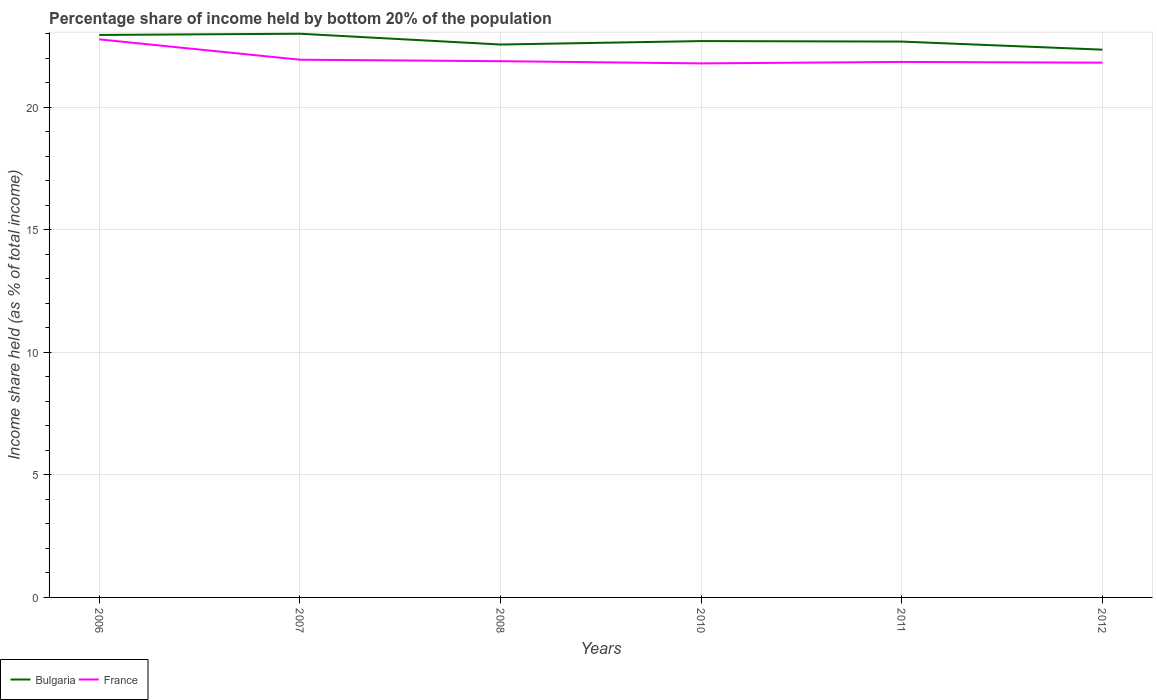Does the line corresponding to Bulgaria intersect with the line corresponding to France?
Your answer should be compact. No. Is the number of lines equal to the number of legend labels?
Make the answer very short. Yes. Across all years, what is the maximum share of income held by bottom 20% of the population in France?
Give a very brief answer. 21.79. In which year was the share of income held by bottom 20% of the population in France maximum?
Give a very brief answer. 2010. What is the total share of income held by bottom 20% of the population in Bulgaria in the graph?
Ensure brevity in your answer.  0.39. What is the difference between the highest and the second highest share of income held by bottom 20% of the population in France?
Make the answer very short. 0.98. What is the difference between the highest and the lowest share of income held by bottom 20% of the population in Bulgaria?
Your answer should be very brief. 2. Is the share of income held by bottom 20% of the population in France strictly greater than the share of income held by bottom 20% of the population in Bulgaria over the years?
Make the answer very short. Yes. How many lines are there?
Keep it short and to the point. 2. What is the difference between two consecutive major ticks on the Y-axis?
Provide a short and direct response. 5. Are the values on the major ticks of Y-axis written in scientific E-notation?
Provide a succinct answer. No. What is the title of the graph?
Keep it short and to the point. Percentage share of income held by bottom 20% of the population. Does "Palau" appear as one of the legend labels in the graph?
Provide a short and direct response. No. What is the label or title of the Y-axis?
Your answer should be very brief. Income share held (as % of total income). What is the Income share held (as % of total income) of Bulgaria in 2006?
Offer a terse response. 22.95. What is the Income share held (as % of total income) in France in 2006?
Ensure brevity in your answer.  22.77. What is the Income share held (as % of total income) of France in 2007?
Make the answer very short. 21.94. What is the Income share held (as % of total income) in Bulgaria in 2008?
Make the answer very short. 22.56. What is the Income share held (as % of total income) in France in 2008?
Offer a very short reply. 21.88. What is the Income share held (as % of total income) of Bulgaria in 2010?
Keep it short and to the point. 22.7. What is the Income share held (as % of total income) of France in 2010?
Your response must be concise. 21.79. What is the Income share held (as % of total income) in Bulgaria in 2011?
Provide a succinct answer. 22.68. What is the Income share held (as % of total income) of France in 2011?
Your answer should be compact. 21.85. What is the Income share held (as % of total income) in Bulgaria in 2012?
Your response must be concise. 22.35. What is the Income share held (as % of total income) in France in 2012?
Ensure brevity in your answer.  21.82. Across all years, what is the maximum Income share held (as % of total income) in France?
Keep it short and to the point. 22.77. Across all years, what is the minimum Income share held (as % of total income) of Bulgaria?
Make the answer very short. 22.35. Across all years, what is the minimum Income share held (as % of total income) in France?
Offer a very short reply. 21.79. What is the total Income share held (as % of total income) in Bulgaria in the graph?
Give a very brief answer. 136.24. What is the total Income share held (as % of total income) of France in the graph?
Give a very brief answer. 132.05. What is the difference between the Income share held (as % of total income) in France in 2006 and that in 2007?
Give a very brief answer. 0.83. What is the difference between the Income share held (as % of total income) of Bulgaria in 2006 and that in 2008?
Offer a terse response. 0.39. What is the difference between the Income share held (as % of total income) in France in 2006 and that in 2008?
Offer a very short reply. 0.89. What is the difference between the Income share held (as % of total income) of Bulgaria in 2006 and that in 2011?
Make the answer very short. 0.27. What is the difference between the Income share held (as % of total income) of Bulgaria in 2007 and that in 2008?
Give a very brief answer. 0.44. What is the difference between the Income share held (as % of total income) of Bulgaria in 2007 and that in 2010?
Provide a succinct answer. 0.3. What is the difference between the Income share held (as % of total income) of France in 2007 and that in 2010?
Provide a short and direct response. 0.15. What is the difference between the Income share held (as % of total income) in Bulgaria in 2007 and that in 2011?
Provide a short and direct response. 0.32. What is the difference between the Income share held (as % of total income) in France in 2007 and that in 2011?
Your response must be concise. 0.09. What is the difference between the Income share held (as % of total income) of Bulgaria in 2007 and that in 2012?
Provide a short and direct response. 0.65. What is the difference between the Income share held (as % of total income) in France in 2007 and that in 2012?
Keep it short and to the point. 0.12. What is the difference between the Income share held (as % of total income) of Bulgaria in 2008 and that in 2010?
Your answer should be very brief. -0.14. What is the difference between the Income share held (as % of total income) in France in 2008 and that in 2010?
Give a very brief answer. 0.09. What is the difference between the Income share held (as % of total income) of Bulgaria in 2008 and that in 2011?
Offer a very short reply. -0.12. What is the difference between the Income share held (as % of total income) in France in 2008 and that in 2011?
Make the answer very short. 0.03. What is the difference between the Income share held (as % of total income) of Bulgaria in 2008 and that in 2012?
Provide a short and direct response. 0.21. What is the difference between the Income share held (as % of total income) in France in 2008 and that in 2012?
Make the answer very short. 0.06. What is the difference between the Income share held (as % of total income) in Bulgaria in 2010 and that in 2011?
Make the answer very short. 0.02. What is the difference between the Income share held (as % of total income) in France in 2010 and that in 2011?
Offer a terse response. -0.06. What is the difference between the Income share held (as % of total income) of France in 2010 and that in 2012?
Offer a very short reply. -0.03. What is the difference between the Income share held (as % of total income) of Bulgaria in 2011 and that in 2012?
Your answer should be compact. 0.33. What is the difference between the Income share held (as % of total income) in France in 2011 and that in 2012?
Provide a short and direct response. 0.03. What is the difference between the Income share held (as % of total income) in Bulgaria in 2006 and the Income share held (as % of total income) in France in 2007?
Give a very brief answer. 1.01. What is the difference between the Income share held (as % of total income) in Bulgaria in 2006 and the Income share held (as % of total income) in France in 2008?
Your response must be concise. 1.07. What is the difference between the Income share held (as % of total income) of Bulgaria in 2006 and the Income share held (as % of total income) of France in 2010?
Make the answer very short. 1.16. What is the difference between the Income share held (as % of total income) in Bulgaria in 2006 and the Income share held (as % of total income) in France in 2011?
Keep it short and to the point. 1.1. What is the difference between the Income share held (as % of total income) in Bulgaria in 2006 and the Income share held (as % of total income) in France in 2012?
Your answer should be compact. 1.13. What is the difference between the Income share held (as % of total income) in Bulgaria in 2007 and the Income share held (as % of total income) in France in 2008?
Keep it short and to the point. 1.12. What is the difference between the Income share held (as % of total income) in Bulgaria in 2007 and the Income share held (as % of total income) in France in 2010?
Ensure brevity in your answer.  1.21. What is the difference between the Income share held (as % of total income) of Bulgaria in 2007 and the Income share held (as % of total income) of France in 2011?
Ensure brevity in your answer.  1.15. What is the difference between the Income share held (as % of total income) of Bulgaria in 2007 and the Income share held (as % of total income) of France in 2012?
Your answer should be very brief. 1.18. What is the difference between the Income share held (as % of total income) of Bulgaria in 2008 and the Income share held (as % of total income) of France in 2010?
Offer a terse response. 0.77. What is the difference between the Income share held (as % of total income) in Bulgaria in 2008 and the Income share held (as % of total income) in France in 2011?
Your answer should be very brief. 0.71. What is the difference between the Income share held (as % of total income) in Bulgaria in 2008 and the Income share held (as % of total income) in France in 2012?
Offer a terse response. 0.74. What is the difference between the Income share held (as % of total income) in Bulgaria in 2011 and the Income share held (as % of total income) in France in 2012?
Provide a short and direct response. 0.86. What is the average Income share held (as % of total income) of Bulgaria per year?
Give a very brief answer. 22.71. What is the average Income share held (as % of total income) in France per year?
Keep it short and to the point. 22.01. In the year 2006, what is the difference between the Income share held (as % of total income) of Bulgaria and Income share held (as % of total income) of France?
Give a very brief answer. 0.18. In the year 2007, what is the difference between the Income share held (as % of total income) in Bulgaria and Income share held (as % of total income) in France?
Offer a very short reply. 1.06. In the year 2008, what is the difference between the Income share held (as % of total income) of Bulgaria and Income share held (as % of total income) of France?
Your answer should be very brief. 0.68. In the year 2010, what is the difference between the Income share held (as % of total income) of Bulgaria and Income share held (as % of total income) of France?
Keep it short and to the point. 0.91. In the year 2011, what is the difference between the Income share held (as % of total income) in Bulgaria and Income share held (as % of total income) in France?
Keep it short and to the point. 0.83. In the year 2012, what is the difference between the Income share held (as % of total income) in Bulgaria and Income share held (as % of total income) in France?
Offer a very short reply. 0.53. What is the ratio of the Income share held (as % of total income) in France in 2006 to that in 2007?
Make the answer very short. 1.04. What is the ratio of the Income share held (as % of total income) in Bulgaria in 2006 to that in 2008?
Keep it short and to the point. 1.02. What is the ratio of the Income share held (as % of total income) of France in 2006 to that in 2008?
Ensure brevity in your answer.  1.04. What is the ratio of the Income share held (as % of total income) in Bulgaria in 2006 to that in 2010?
Make the answer very short. 1.01. What is the ratio of the Income share held (as % of total income) in France in 2006 to that in 2010?
Provide a short and direct response. 1.04. What is the ratio of the Income share held (as % of total income) in Bulgaria in 2006 to that in 2011?
Keep it short and to the point. 1.01. What is the ratio of the Income share held (as % of total income) in France in 2006 to that in 2011?
Keep it short and to the point. 1.04. What is the ratio of the Income share held (as % of total income) in Bulgaria in 2006 to that in 2012?
Your answer should be very brief. 1.03. What is the ratio of the Income share held (as % of total income) in France in 2006 to that in 2012?
Offer a very short reply. 1.04. What is the ratio of the Income share held (as % of total income) in Bulgaria in 2007 to that in 2008?
Provide a succinct answer. 1.02. What is the ratio of the Income share held (as % of total income) in France in 2007 to that in 2008?
Keep it short and to the point. 1. What is the ratio of the Income share held (as % of total income) in Bulgaria in 2007 to that in 2010?
Your response must be concise. 1.01. What is the ratio of the Income share held (as % of total income) in France in 2007 to that in 2010?
Make the answer very short. 1.01. What is the ratio of the Income share held (as % of total income) in Bulgaria in 2007 to that in 2011?
Provide a short and direct response. 1.01. What is the ratio of the Income share held (as % of total income) of Bulgaria in 2007 to that in 2012?
Make the answer very short. 1.03. What is the ratio of the Income share held (as % of total income) in France in 2007 to that in 2012?
Ensure brevity in your answer.  1.01. What is the ratio of the Income share held (as % of total income) of France in 2008 to that in 2010?
Make the answer very short. 1. What is the ratio of the Income share held (as % of total income) in Bulgaria in 2008 to that in 2012?
Your answer should be compact. 1.01. What is the ratio of the Income share held (as % of total income) of Bulgaria in 2010 to that in 2011?
Give a very brief answer. 1. What is the ratio of the Income share held (as % of total income) of France in 2010 to that in 2011?
Your answer should be compact. 1. What is the ratio of the Income share held (as % of total income) of Bulgaria in 2010 to that in 2012?
Make the answer very short. 1.02. What is the ratio of the Income share held (as % of total income) of France in 2010 to that in 2012?
Make the answer very short. 1. What is the ratio of the Income share held (as % of total income) of Bulgaria in 2011 to that in 2012?
Offer a very short reply. 1.01. What is the difference between the highest and the second highest Income share held (as % of total income) in Bulgaria?
Offer a very short reply. 0.05. What is the difference between the highest and the second highest Income share held (as % of total income) of France?
Keep it short and to the point. 0.83. What is the difference between the highest and the lowest Income share held (as % of total income) in Bulgaria?
Give a very brief answer. 0.65. What is the difference between the highest and the lowest Income share held (as % of total income) of France?
Offer a terse response. 0.98. 